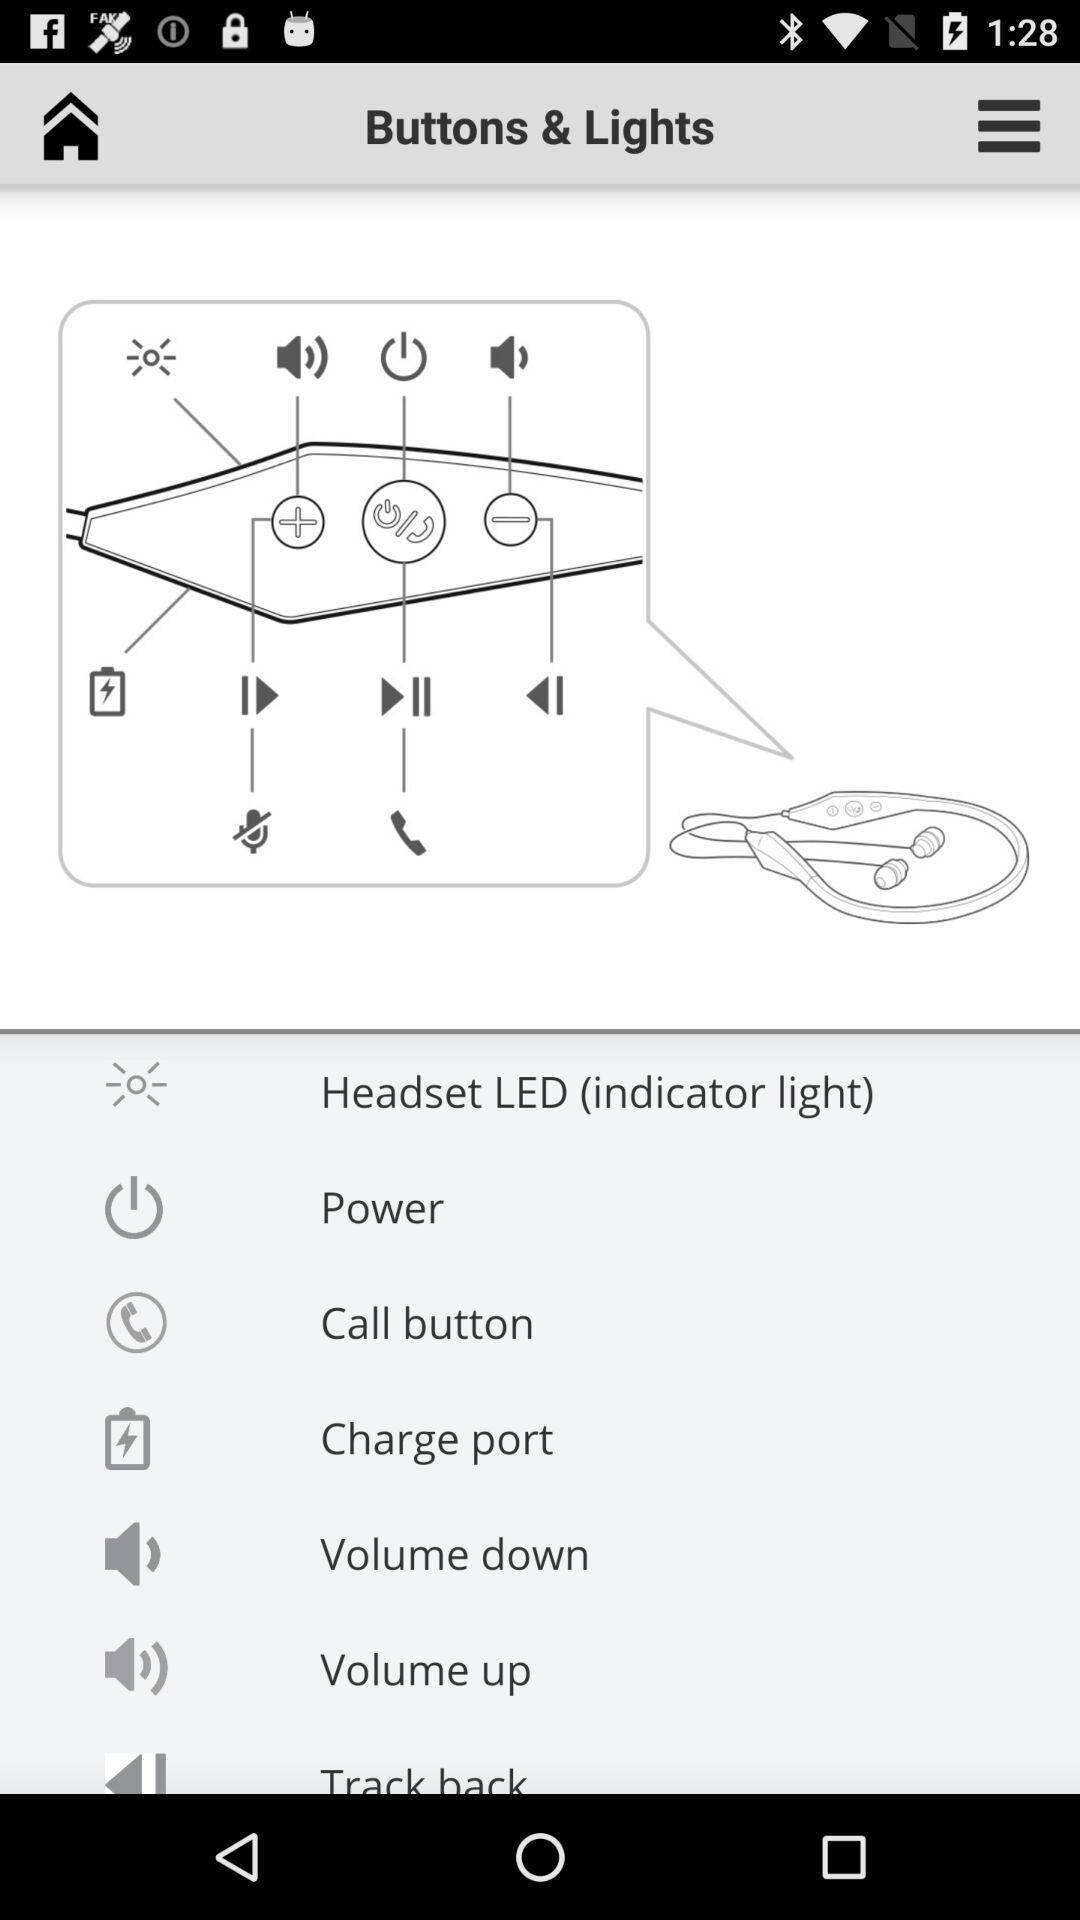What is the application name? The application name is "Buttons & Lights". 